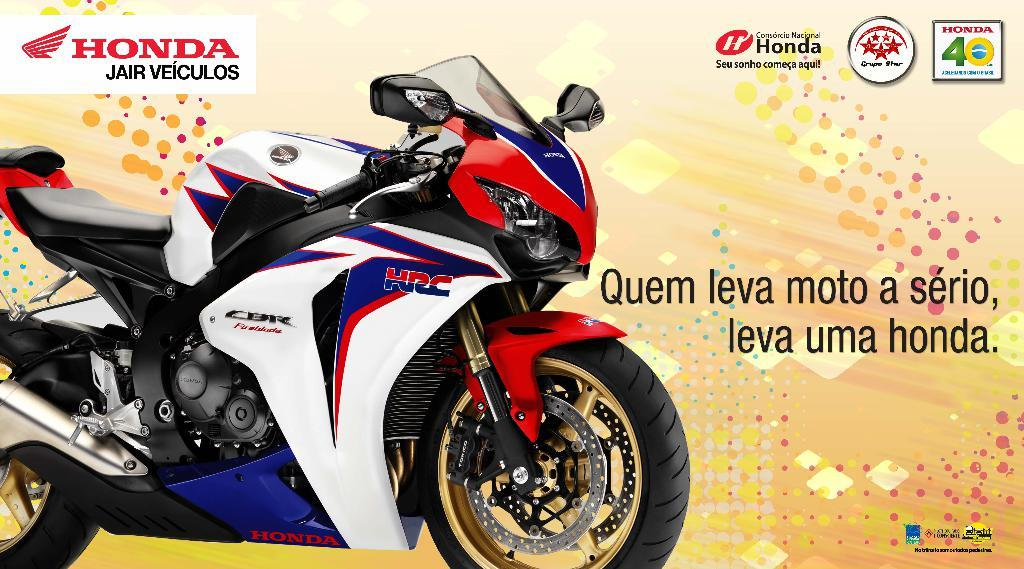What type of vehicle is in the image? There is a colorful bike in the image. What else can be seen in the image besides the bike? There is text and a colorful design on the image. What type of wax is being used to create the design on the bike? There is no wax present in the image, and the design is part of the image itself, not a separate substance applied to the bike. 